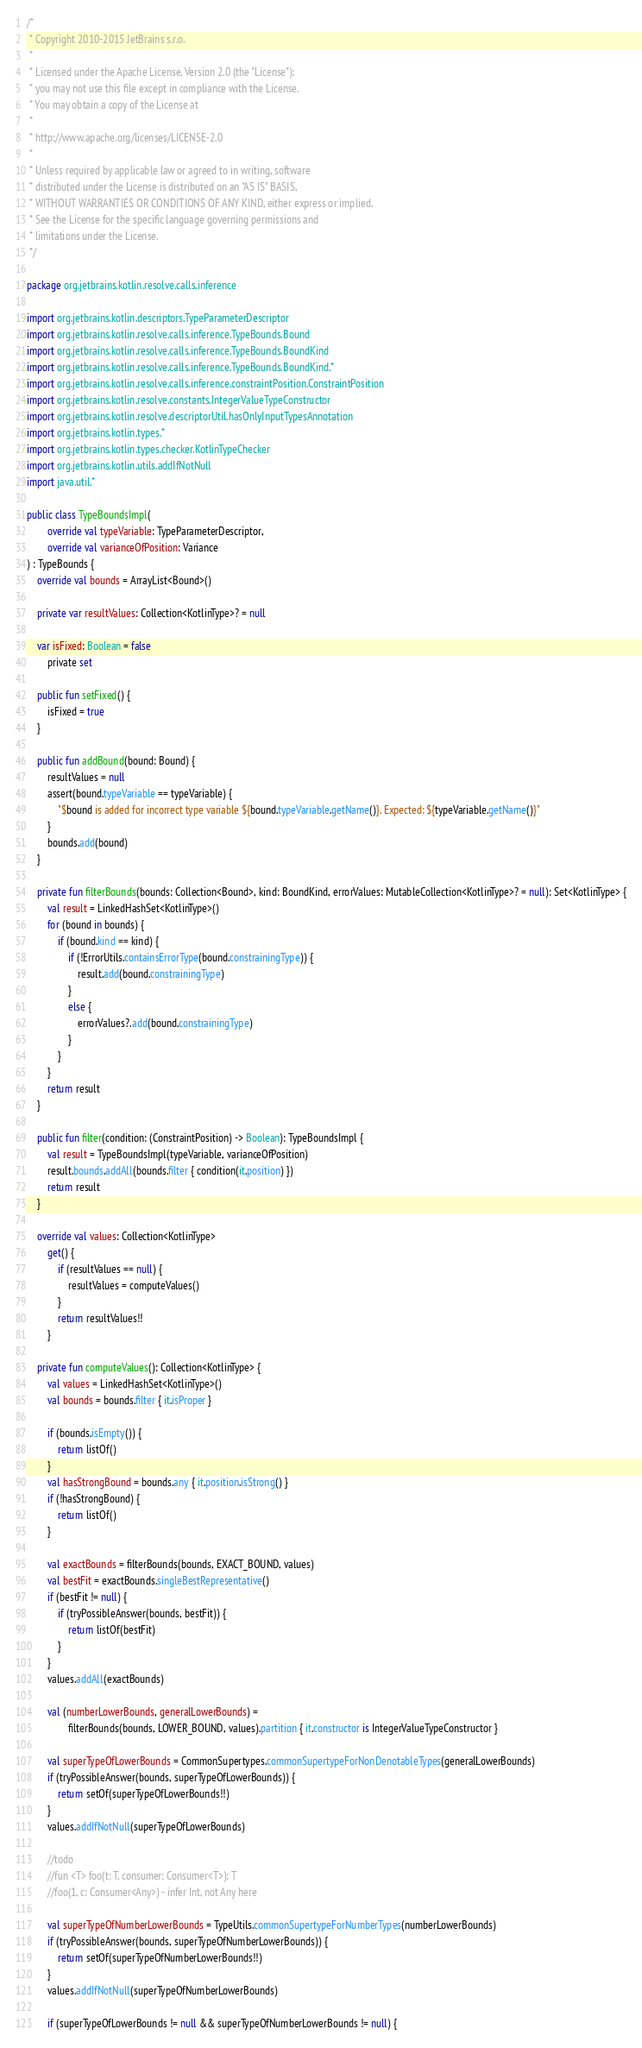<code> <loc_0><loc_0><loc_500><loc_500><_Kotlin_>/*
 * Copyright 2010-2015 JetBrains s.r.o.
 *
 * Licensed under the Apache License, Version 2.0 (the "License");
 * you may not use this file except in compliance with the License.
 * You may obtain a copy of the License at
 *
 * http://www.apache.org/licenses/LICENSE-2.0
 *
 * Unless required by applicable law or agreed to in writing, software
 * distributed under the License is distributed on an "AS IS" BASIS,
 * WITHOUT WARRANTIES OR CONDITIONS OF ANY KIND, either express or implied.
 * See the License for the specific language governing permissions and
 * limitations under the License.
 */

package org.jetbrains.kotlin.resolve.calls.inference

import org.jetbrains.kotlin.descriptors.TypeParameterDescriptor
import org.jetbrains.kotlin.resolve.calls.inference.TypeBounds.Bound
import org.jetbrains.kotlin.resolve.calls.inference.TypeBounds.BoundKind
import org.jetbrains.kotlin.resolve.calls.inference.TypeBounds.BoundKind.*
import org.jetbrains.kotlin.resolve.calls.inference.constraintPosition.ConstraintPosition
import org.jetbrains.kotlin.resolve.constants.IntegerValueTypeConstructor
import org.jetbrains.kotlin.resolve.descriptorUtil.hasOnlyInputTypesAnnotation
import org.jetbrains.kotlin.types.*
import org.jetbrains.kotlin.types.checker.KotlinTypeChecker
import org.jetbrains.kotlin.utils.addIfNotNull
import java.util.*

public class TypeBoundsImpl(
        override val typeVariable: TypeParameterDescriptor,
        override val varianceOfPosition: Variance
) : TypeBounds {
    override val bounds = ArrayList<Bound>()

    private var resultValues: Collection<KotlinType>? = null

    var isFixed: Boolean = false
        private set

    public fun setFixed() {
        isFixed = true
    }

    public fun addBound(bound: Bound) {
        resultValues = null
        assert(bound.typeVariable == typeVariable) {
            "$bound is added for incorrect type variable ${bound.typeVariable.getName()}. Expected: ${typeVariable.getName()}"
        }
        bounds.add(bound)
    }

    private fun filterBounds(bounds: Collection<Bound>, kind: BoundKind, errorValues: MutableCollection<KotlinType>? = null): Set<KotlinType> {
        val result = LinkedHashSet<KotlinType>()
        for (bound in bounds) {
            if (bound.kind == kind) {
                if (!ErrorUtils.containsErrorType(bound.constrainingType)) {
                    result.add(bound.constrainingType)
                }
                else {
                    errorValues?.add(bound.constrainingType)
                }
            }
        }
        return result
    }

    public fun filter(condition: (ConstraintPosition) -> Boolean): TypeBoundsImpl {
        val result = TypeBoundsImpl(typeVariable, varianceOfPosition)
        result.bounds.addAll(bounds.filter { condition(it.position) })
        return result
    }

    override val values: Collection<KotlinType>
        get() {
            if (resultValues == null) {
                resultValues = computeValues()
            }
            return resultValues!!
        }

    private fun computeValues(): Collection<KotlinType> {
        val values = LinkedHashSet<KotlinType>()
        val bounds = bounds.filter { it.isProper }

        if (bounds.isEmpty()) {
            return listOf()
        }
        val hasStrongBound = bounds.any { it.position.isStrong() }
        if (!hasStrongBound) {
            return listOf()
        }

        val exactBounds = filterBounds(bounds, EXACT_BOUND, values)
        val bestFit = exactBounds.singleBestRepresentative()
        if (bestFit != null) {
            if (tryPossibleAnswer(bounds, bestFit)) {
                return listOf(bestFit)
            }
        }
        values.addAll(exactBounds)

        val (numberLowerBounds, generalLowerBounds) =
                filterBounds(bounds, LOWER_BOUND, values).partition { it.constructor is IntegerValueTypeConstructor }

        val superTypeOfLowerBounds = CommonSupertypes.commonSupertypeForNonDenotableTypes(generalLowerBounds)
        if (tryPossibleAnswer(bounds, superTypeOfLowerBounds)) {
            return setOf(superTypeOfLowerBounds!!)
        }
        values.addIfNotNull(superTypeOfLowerBounds)

        //todo
        //fun <T> foo(t: T, consumer: Consumer<T>): T
        //foo(1, c: Consumer<Any>) - infer Int, not Any here

        val superTypeOfNumberLowerBounds = TypeUtils.commonSupertypeForNumberTypes(numberLowerBounds)
        if (tryPossibleAnswer(bounds, superTypeOfNumberLowerBounds)) {
            return setOf(superTypeOfNumberLowerBounds!!)
        }
        values.addIfNotNull(superTypeOfNumberLowerBounds)

        if (superTypeOfLowerBounds != null && superTypeOfNumberLowerBounds != null) {</code> 